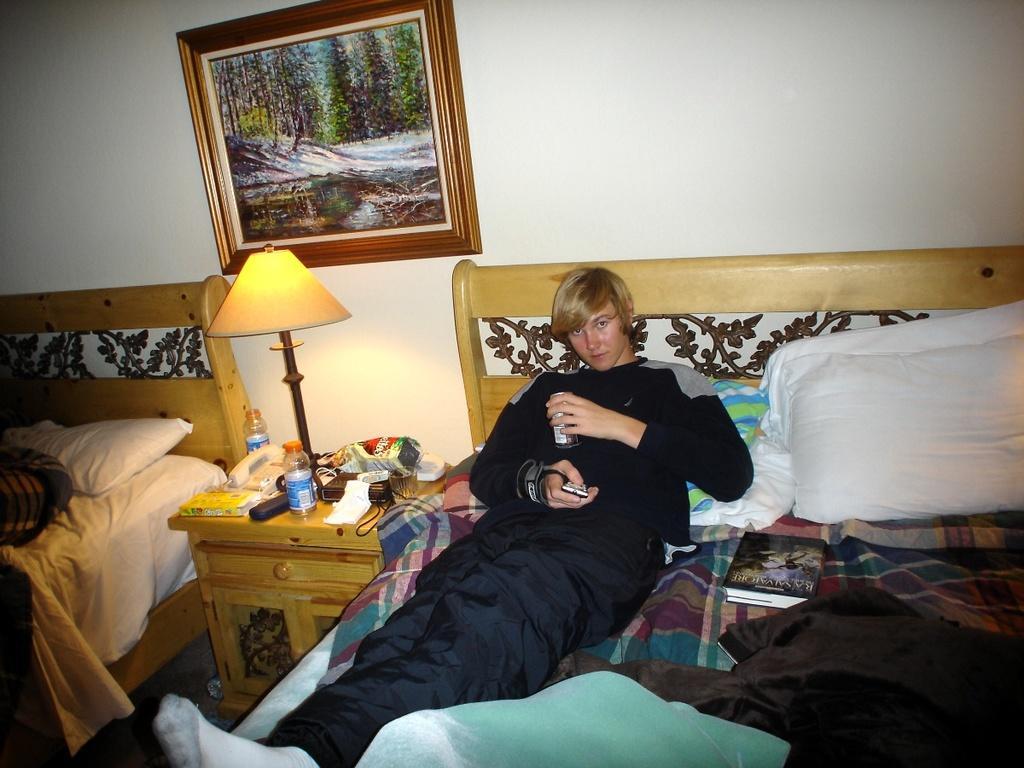Describe this image in one or two sentences. In this image I see 2 beds and on this bed I see this man lying here and he is holding a can and there is a book over here, I can also see there are few things on the table and I see a lamp. In the background I see the wall and the photo frame. 